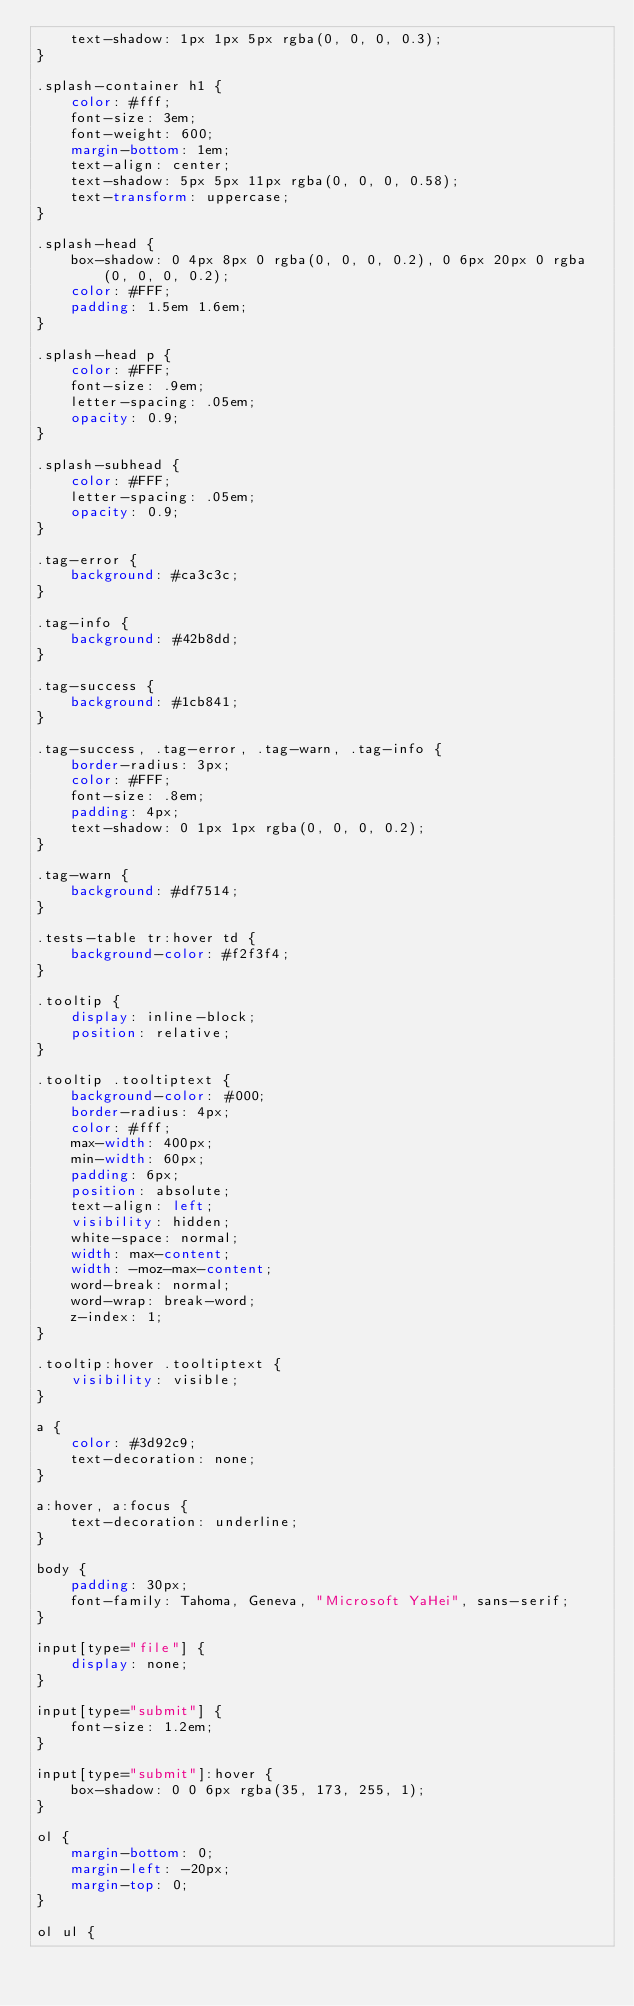<code> <loc_0><loc_0><loc_500><loc_500><_CSS_>    text-shadow: 1px 1px 5px rgba(0, 0, 0, 0.3);
}

.splash-container h1 {
    color: #fff;
    font-size: 3em;
    font-weight: 600;
    margin-bottom: 1em;
    text-align: center;
    text-shadow: 5px 5px 11px rgba(0, 0, 0, 0.58);
    text-transform: uppercase;
}

.splash-head {
    box-shadow: 0 4px 8px 0 rgba(0, 0, 0, 0.2), 0 6px 20px 0 rgba(0, 0, 0, 0.2);
    color: #FFF;
    padding: 1.5em 1.6em;
}

.splash-head p {
    color: #FFF;
    font-size: .9em;
    letter-spacing: .05em;
    opacity: 0.9;
}

.splash-subhead {
    color: #FFF;
    letter-spacing: .05em;
    opacity: 0.9;
}

.tag-error {
    background: #ca3c3c;
}

.tag-info {
    background: #42b8dd;
}

.tag-success {
    background: #1cb841;
}

.tag-success, .tag-error, .tag-warn, .tag-info {
    border-radius: 3px;
    color: #FFF;
    font-size: .8em;
    padding: 4px;
    text-shadow: 0 1px 1px rgba(0, 0, 0, 0.2);
}

.tag-warn {
    background: #df7514;
}

.tests-table tr:hover td {
    background-color: #f2f3f4;
}

.tooltip {
    display: inline-block;
    position: relative;
}

.tooltip .tooltiptext {
    background-color: #000;
    border-radius: 4px;
    color: #fff;
    max-width: 400px;
    min-width: 60px;
    padding: 6px;
    position: absolute;
    text-align: left;
    visibility: hidden;
    white-space: normal;
    width: max-content;
    width: -moz-max-content;
    word-break: normal;
    word-wrap: break-word;
    z-index: 1;
}

.tooltip:hover .tooltiptext {
    visibility: visible;
}

a {
    color: #3d92c9;
    text-decoration: none;
}

a:hover, a:focus {
    text-decoration: underline;
}

body {
    padding: 30px;
    font-family: Tahoma, Geneva, "Microsoft YaHei", sans-serif;
}

input[type="file"] {
    display: none;
}

input[type="submit"] {
    font-size: 1.2em;
}

input[type="submit"]:hover {
    box-shadow: 0 0 6px rgba(35, 173, 255, 1);
}

ol {
    margin-bottom: 0;
    margin-left: -20px;
    margin-top: 0;
}

ol ul {</code> 